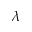<formula> <loc_0><loc_0><loc_500><loc_500>\lambda</formula> 